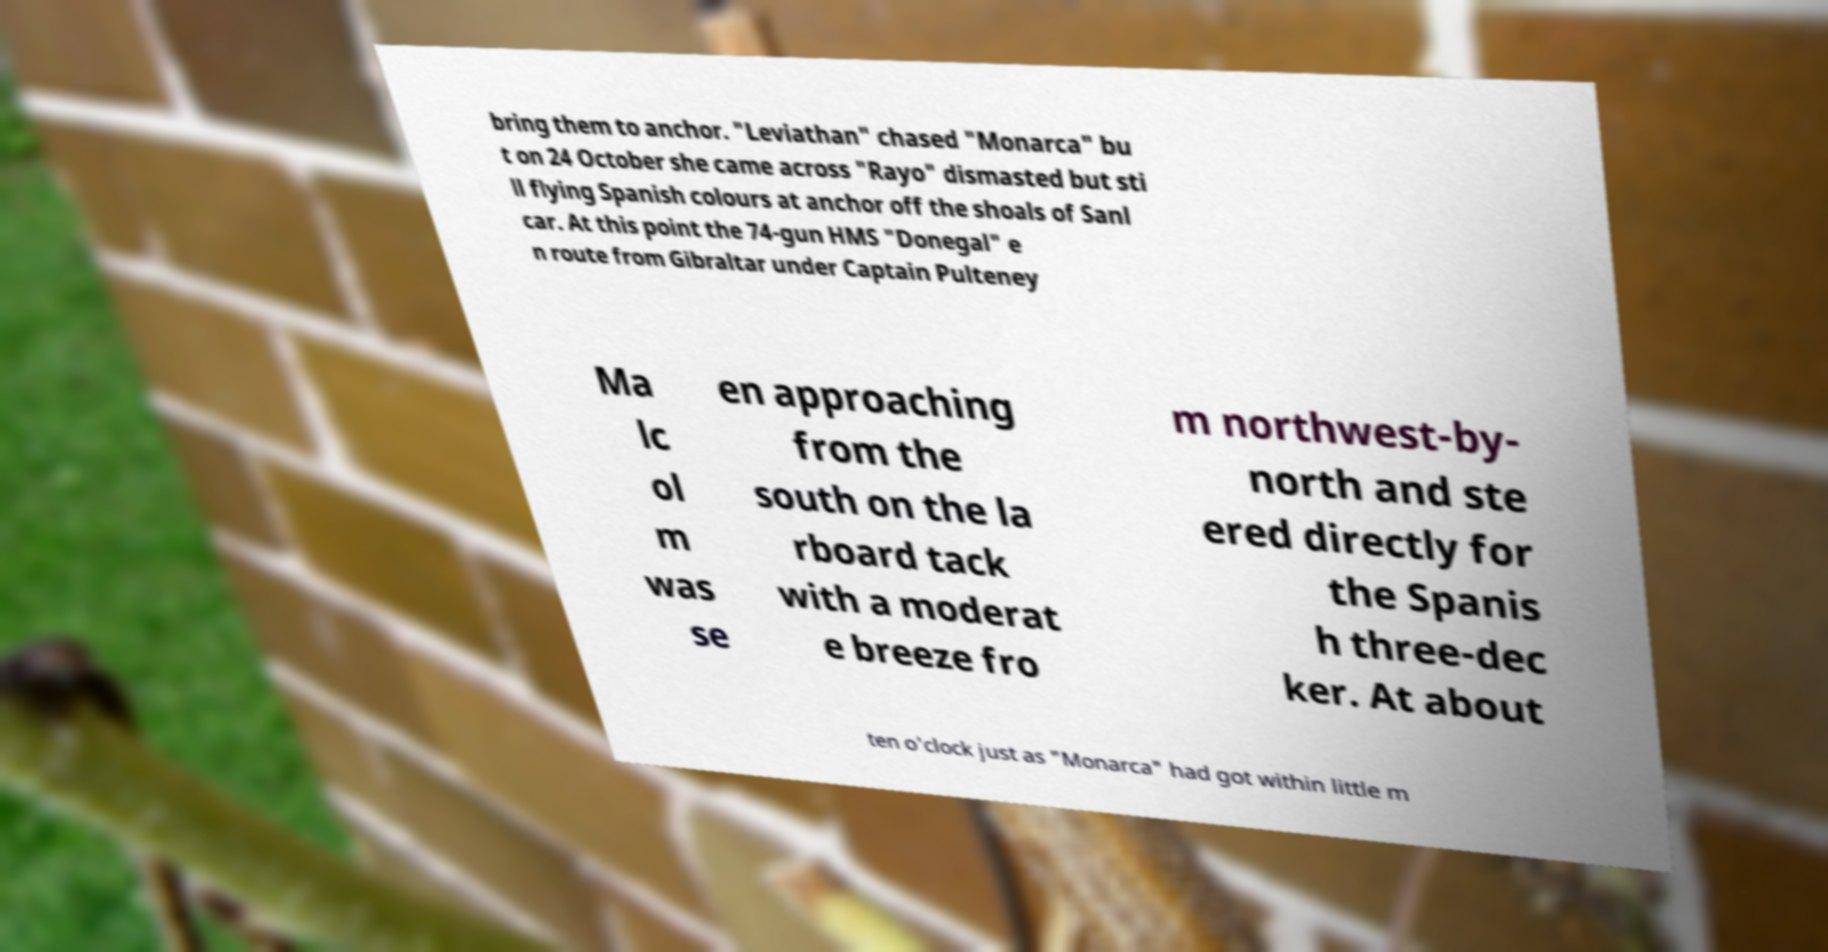I need the written content from this picture converted into text. Can you do that? bring them to anchor. "Leviathan" chased "Monarca" bu t on 24 October she came across "Rayo" dismasted but sti ll flying Spanish colours at anchor off the shoals of Sanl car. At this point the 74-gun HMS "Donegal" e n route from Gibraltar under Captain Pulteney Ma lc ol m was se en approaching from the south on the la rboard tack with a moderat e breeze fro m northwest-by- north and ste ered directly for the Spanis h three-dec ker. At about ten o'clock just as "Monarca" had got within little m 